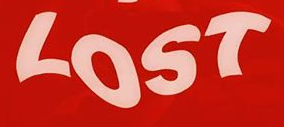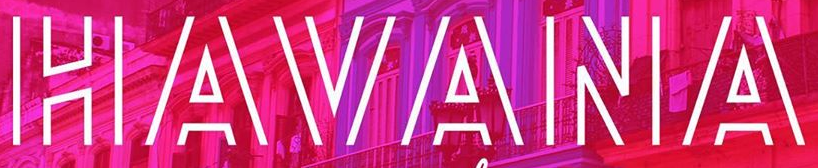What words can you see in these images in sequence, separated by a semicolon? LOST; HAVANA 